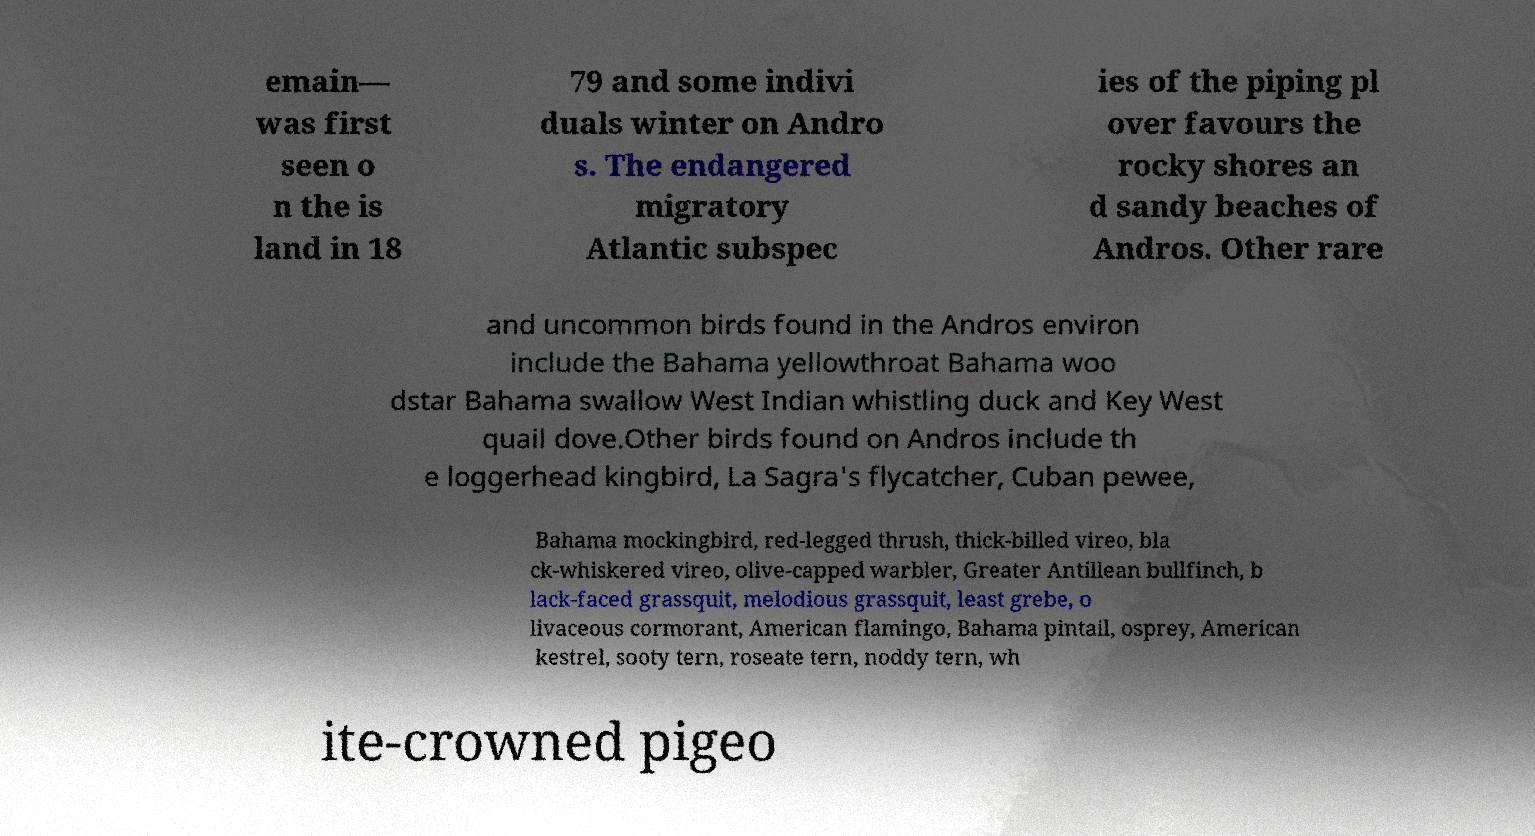Please identify and transcribe the text found in this image. emain— was first seen o n the is land in 18 79 and some indivi duals winter on Andro s. The endangered migratory Atlantic subspec ies of the piping pl over favours the rocky shores an d sandy beaches of Andros. Other rare and uncommon birds found in the Andros environ include the Bahama yellowthroat Bahama woo dstar Bahama swallow West Indian whistling duck and Key West quail dove.Other birds found on Andros include th e loggerhead kingbird, La Sagra's flycatcher, Cuban pewee, Bahama mockingbird, red-legged thrush, thick-billed vireo, bla ck-whiskered vireo, olive-capped warbler, Greater Antillean bullfinch, b lack-faced grassquit, melodious grassquit, least grebe, o livaceous cormorant, American flamingo, Bahama pintail, osprey, American kestrel, sooty tern, roseate tern, noddy tern, wh ite-crowned pigeo 